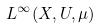Convert formula to latex. <formula><loc_0><loc_0><loc_500><loc_500>L ^ { \infty } ( X , U , \mu )</formula> 